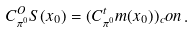Convert formula to latex. <formula><loc_0><loc_0><loc_500><loc_500>C _ { \pi ^ { 0 } } ^ { O } S ( x _ { 0 } ) = ( C _ { \pi ^ { 0 } } ^ { t } m ( x _ { 0 } ) ) _ { c } o n \, .</formula> 